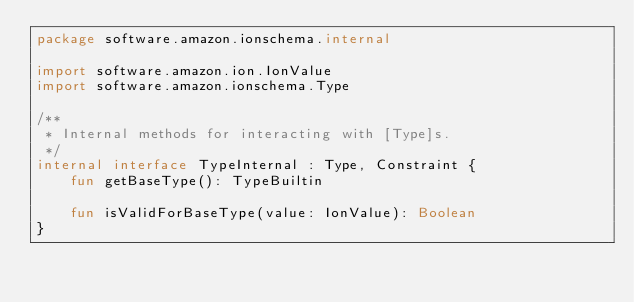Convert code to text. <code><loc_0><loc_0><loc_500><loc_500><_Kotlin_>package software.amazon.ionschema.internal

import software.amazon.ion.IonValue
import software.amazon.ionschema.Type

/**
 * Internal methods for interacting with [Type]s.
 */
internal interface TypeInternal : Type, Constraint {
    fun getBaseType(): TypeBuiltin

    fun isValidForBaseType(value: IonValue): Boolean
}

</code> 